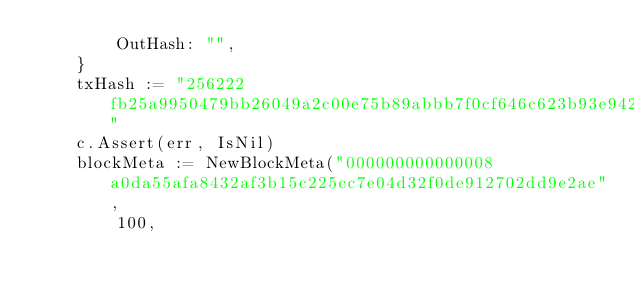Convert code to text. <code><loc_0><loc_0><loc_500><loc_500><_Go_>		OutHash: "",
	}
	txHash := "256222fb25a9950479bb26049a2c00e75b89abbb7f0cf646c623b93e942c4c34"
	c.Assert(err, IsNil)
	blockMeta := NewBlockMeta("000000000000008a0da55afa8432af3b15c225cc7e04d32f0de912702dd9e2ae",
		100,</code> 